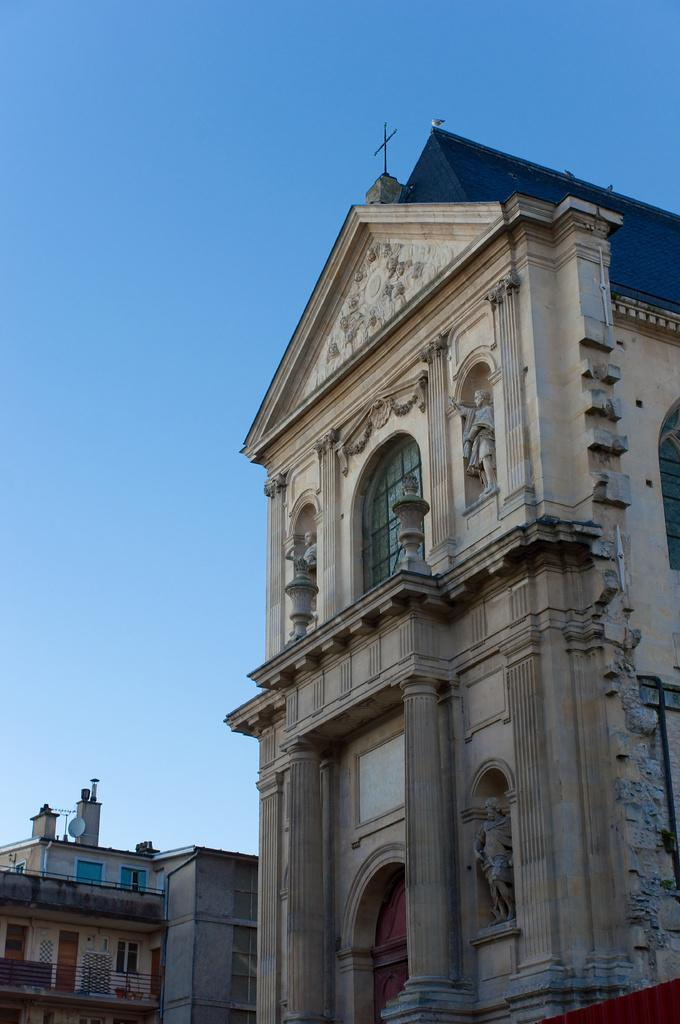What type of building is depicted in the image? The building in the image resembles a church. Can you identify any specific features of the church? Yes, the church has a cross symbol on top of it. What is the color of the sky in the image? The sky is blue in the image. Can you tell me how many bombs are visible in the image? There are no bombs present in the image; it features a church with a cross symbol on top. Is there a river flowing near the church in the image? There is no river visible in the image; it only shows the church and the blue sky. 